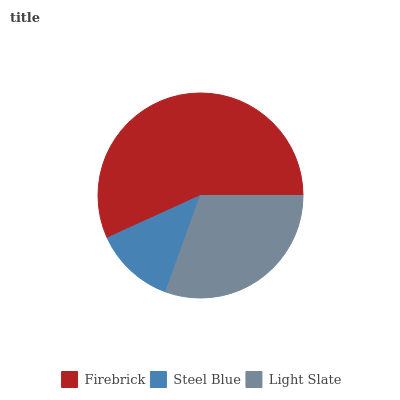Is Steel Blue the minimum?
Answer yes or no. Yes. Is Firebrick the maximum?
Answer yes or no. Yes. Is Light Slate the minimum?
Answer yes or no. No. Is Light Slate the maximum?
Answer yes or no. No. Is Light Slate greater than Steel Blue?
Answer yes or no. Yes. Is Steel Blue less than Light Slate?
Answer yes or no. Yes. Is Steel Blue greater than Light Slate?
Answer yes or no. No. Is Light Slate less than Steel Blue?
Answer yes or no. No. Is Light Slate the high median?
Answer yes or no. Yes. Is Light Slate the low median?
Answer yes or no. Yes. Is Steel Blue the high median?
Answer yes or no. No. Is Firebrick the low median?
Answer yes or no. No. 